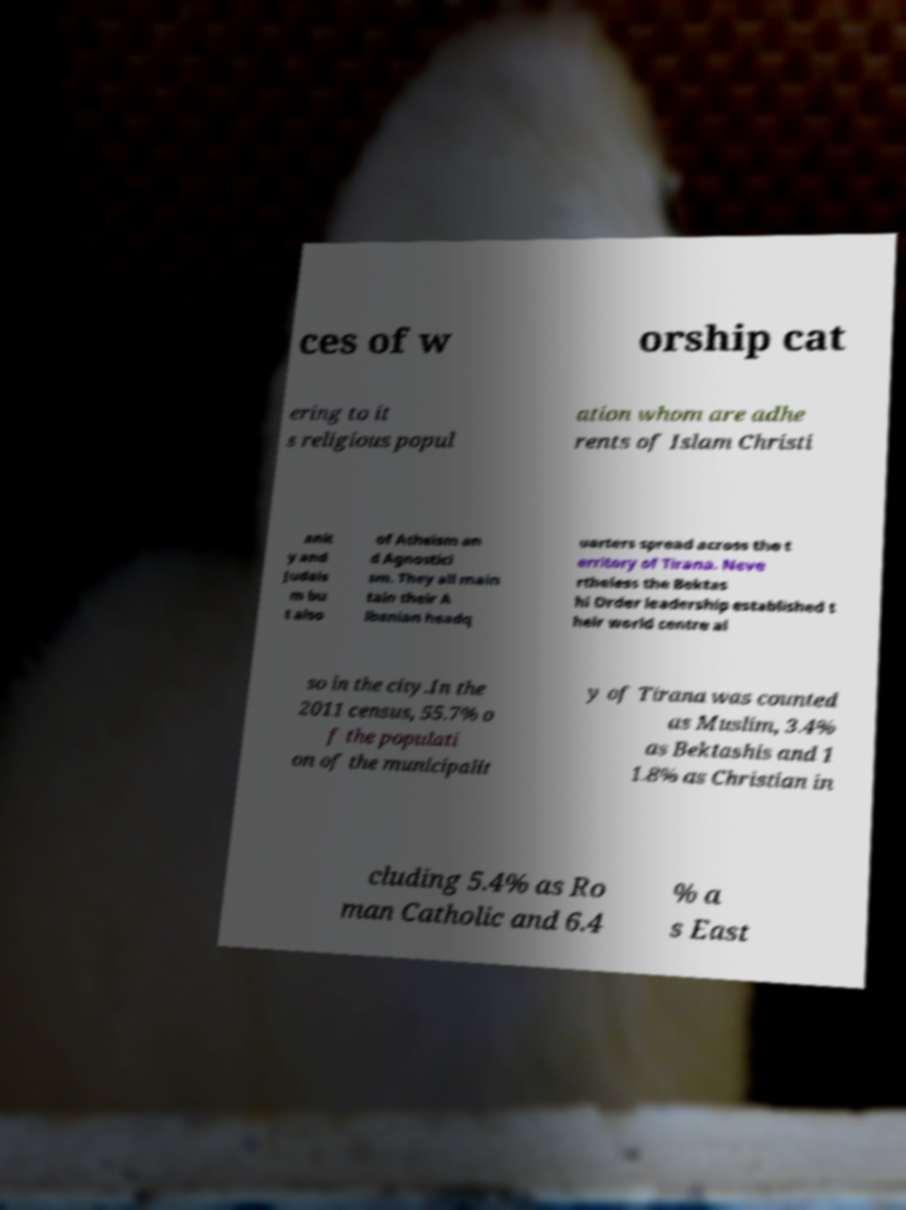There's text embedded in this image that I need extracted. Can you transcribe it verbatim? ces of w orship cat ering to it s religious popul ation whom are adhe rents of Islam Christi anit y and Judais m bu t also of Atheism an d Agnostici sm. They all main tain their A lbanian headq uarters spread across the t erritory of Tirana. Neve rtheless the Bektas hi Order leadership established t heir world centre al so in the city.In the 2011 census, 55.7% o f the populati on of the municipalit y of Tirana was counted as Muslim, 3.4% as Bektashis and 1 1.8% as Christian in cluding 5.4% as Ro man Catholic and 6.4 % a s East 